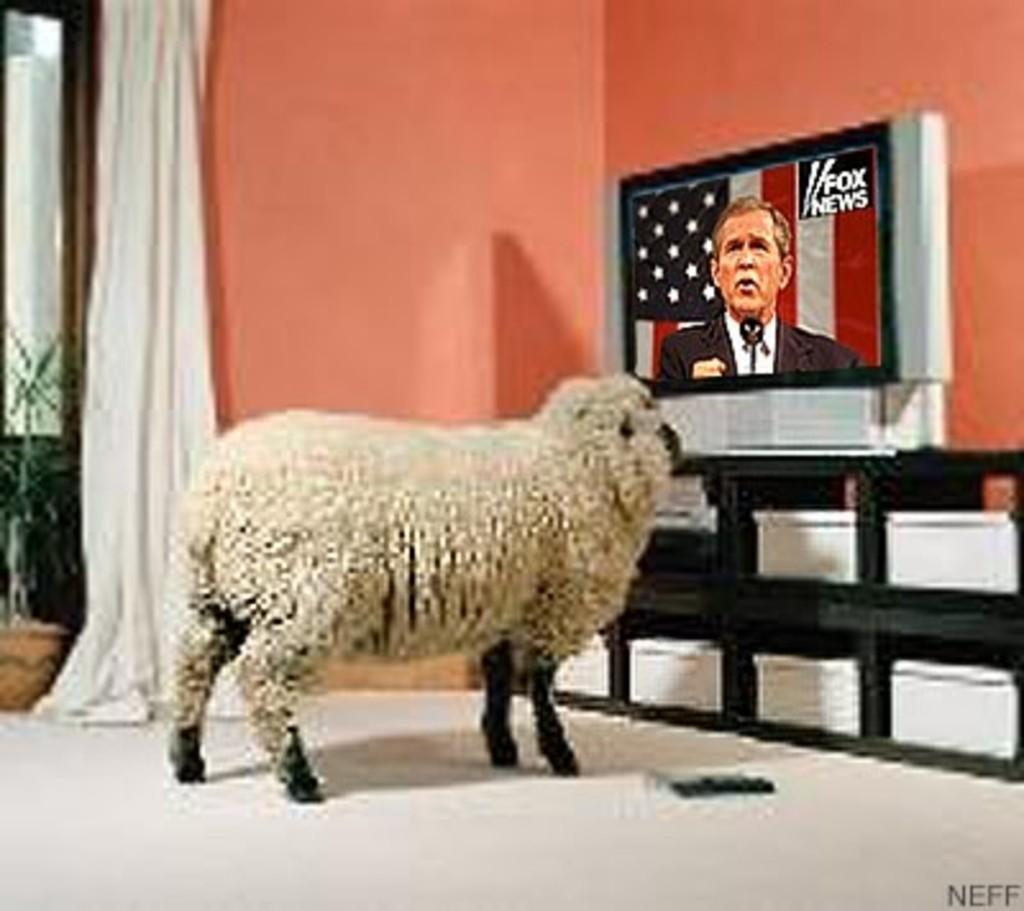What type of animal is present in the image? There is a sheep in the image. What type of covering is visible in the image? There is a curtain in the image. What electronic device is present in the image? There is a television in the image. Where is the television placed in the image? The television is on a rack in the image. Can you tell me how many times the sheep runs across the room in the image? There is no indication of the sheep running in the image; it is stationary. What type of gardening tool is present in the image? There is no gardening tool, such as a rake, present in the image. 